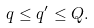<formula> <loc_0><loc_0><loc_500><loc_500>q \leq q ^ { \prime } \leq Q .</formula> 